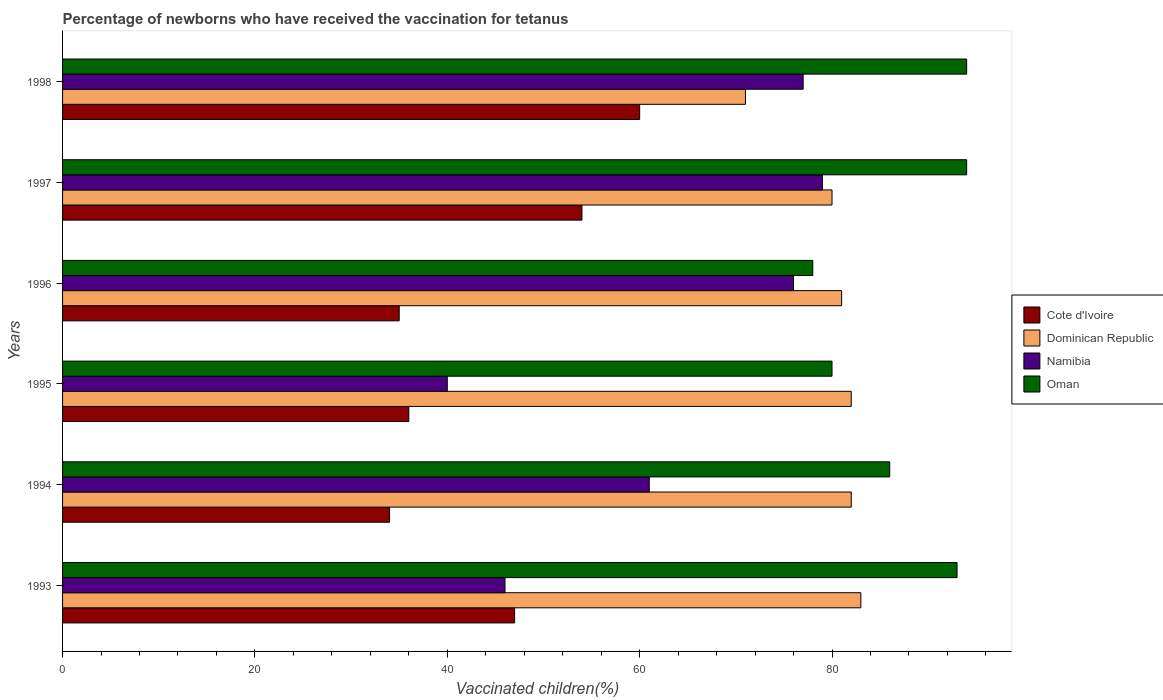How many groups of bars are there?
Your response must be concise. 6. Are the number of bars on each tick of the Y-axis equal?
Provide a succinct answer. Yes. How many bars are there on the 4th tick from the bottom?
Offer a very short reply. 4. What is the percentage of vaccinated children in Cote d'Ivoire in 1998?
Provide a short and direct response. 60. Across all years, what is the maximum percentage of vaccinated children in Namibia?
Your response must be concise. 79. Across all years, what is the minimum percentage of vaccinated children in Oman?
Your response must be concise. 78. In which year was the percentage of vaccinated children in Oman maximum?
Provide a short and direct response. 1997. What is the total percentage of vaccinated children in Cote d'Ivoire in the graph?
Offer a terse response. 266. What is the average percentage of vaccinated children in Dominican Republic per year?
Give a very brief answer. 79.83. In how many years, is the percentage of vaccinated children in Oman greater than 8 %?
Your answer should be very brief. 6. What is the ratio of the percentage of vaccinated children in Cote d'Ivoire in 1993 to that in 1995?
Your response must be concise. 1.31. Is the difference between the percentage of vaccinated children in Oman in 1994 and 1997 greater than the difference between the percentage of vaccinated children in Namibia in 1994 and 1997?
Provide a succinct answer. Yes. What is the difference between the highest and the second highest percentage of vaccinated children in Namibia?
Offer a very short reply. 2. What is the difference between the highest and the lowest percentage of vaccinated children in Dominican Republic?
Your answer should be very brief. 12. In how many years, is the percentage of vaccinated children in Dominican Republic greater than the average percentage of vaccinated children in Dominican Republic taken over all years?
Provide a succinct answer. 5. What does the 2nd bar from the top in 1996 represents?
Provide a succinct answer. Namibia. What does the 1st bar from the bottom in 1993 represents?
Offer a very short reply. Cote d'Ivoire. Is it the case that in every year, the sum of the percentage of vaccinated children in Oman and percentage of vaccinated children in Dominican Republic is greater than the percentage of vaccinated children in Namibia?
Provide a succinct answer. Yes. How many bars are there?
Your answer should be compact. 24. What is the difference between two consecutive major ticks on the X-axis?
Provide a short and direct response. 20. Does the graph contain any zero values?
Keep it short and to the point. No. Does the graph contain grids?
Your answer should be compact. No. Where does the legend appear in the graph?
Provide a succinct answer. Center right. How are the legend labels stacked?
Offer a very short reply. Vertical. What is the title of the graph?
Provide a succinct answer. Percentage of newborns who have received the vaccination for tetanus. What is the label or title of the X-axis?
Provide a short and direct response. Vaccinated children(%). What is the Vaccinated children(%) in Dominican Republic in 1993?
Give a very brief answer. 83. What is the Vaccinated children(%) in Oman in 1993?
Keep it short and to the point. 93. What is the Vaccinated children(%) of Cote d'Ivoire in 1994?
Your answer should be very brief. 34. What is the Vaccinated children(%) in Namibia in 1994?
Give a very brief answer. 61. What is the Vaccinated children(%) in Oman in 1994?
Your answer should be very brief. 86. What is the Vaccinated children(%) of Cote d'Ivoire in 1995?
Give a very brief answer. 36. What is the Vaccinated children(%) in Cote d'Ivoire in 1996?
Provide a succinct answer. 35. What is the Vaccinated children(%) of Dominican Republic in 1996?
Give a very brief answer. 81. What is the Vaccinated children(%) in Oman in 1996?
Your answer should be compact. 78. What is the Vaccinated children(%) in Namibia in 1997?
Offer a terse response. 79. What is the Vaccinated children(%) of Oman in 1997?
Keep it short and to the point. 94. What is the Vaccinated children(%) of Oman in 1998?
Provide a short and direct response. 94. Across all years, what is the maximum Vaccinated children(%) of Namibia?
Provide a succinct answer. 79. Across all years, what is the maximum Vaccinated children(%) of Oman?
Make the answer very short. 94. Across all years, what is the minimum Vaccinated children(%) in Cote d'Ivoire?
Make the answer very short. 34. Across all years, what is the minimum Vaccinated children(%) of Oman?
Ensure brevity in your answer.  78. What is the total Vaccinated children(%) in Cote d'Ivoire in the graph?
Offer a terse response. 266. What is the total Vaccinated children(%) of Dominican Republic in the graph?
Ensure brevity in your answer.  479. What is the total Vaccinated children(%) in Namibia in the graph?
Offer a terse response. 379. What is the total Vaccinated children(%) in Oman in the graph?
Provide a succinct answer. 525. What is the difference between the Vaccinated children(%) in Oman in 1993 and that in 1994?
Offer a terse response. 7. What is the difference between the Vaccinated children(%) of Oman in 1993 and that in 1995?
Give a very brief answer. 13. What is the difference between the Vaccinated children(%) of Cote d'Ivoire in 1993 and that in 1996?
Provide a succinct answer. 12. What is the difference between the Vaccinated children(%) in Dominican Republic in 1993 and that in 1996?
Ensure brevity in your answer.  2. What is the difference between the Vaccinated children(%) of Namibia in 1993 and that in 1996?
Offer a terse response. -30. What is the difference between the Vaccinated children(%) in Cote d'Ivoire in 1993 and that in 1997?
Your answer should be compact. -7. What is the difference between the Vaccinated children(%) in Namibia in 1993 and that in 1997?
Ensure brevity in your answer.  -33. What is the difference between the Vaccinated children(%) of Cote d'Ivoire in 1993 and that in 1998?
Offer a terse response. -13. What is the difference between the Vaccinated children(%) of Namibia in 1993 and that in 1998?
Give a very brief answer. -31. What is the difference between the Vaccinated children(%) in Dominican Republic in 1994 and that in 1995?
Your response must be concise. 0. What is the difference between the Vaccinated children(%) of Oman in 1994 and that in 1995?
Your answer should be very brief. 6. What is the difference between the Vaccinated children(%) in Cote d'Ivoire in 1994 and that in 1996?
Provide a short and direct response. -1. What is the difference between the Vaccinated children(%) in Namibia in 1994 and that in 1996?
Offer a very short reply. -15. What is the difference between the Vaccinated children(%) in Oman in 1994 and that in 1996?
Your answer should be compact. 8. What is the difference between the Vaccinated children(%) of Dominican Republic in 1994 and that in 1997?
Keep it short and to the point. 2. What is the difference between the Vaccinated children(%) of Oman in 1994 and that in 1997?
Provide a succinct answer. -8. What is the difference between the Vaccinated children(%) of Cote d'Ivoire in 1994 and that in 1998?
Offer a very short reply. -26. What is the difference between the Vaccinated children(%) in Cote d'Ivoire in 1995 and that in 1996?
Your response must be concise. 1. What is the difference between the Vaccinated children(%) of Namibia in 1995 and that in 1996?
Provide a succinct answer. -36. What is the difference between the Vaccinated children(%) of Cote d'Ivoire in 1995 and that in 1997?
Give a very brief answer. -18. What is the difference between the Vaccinated children(%) in Namibia in 1995 and that in 1997?
Give a very brief answer. -39. What is the difference between the Vaccinated children(%) of Oman in 1995 and that in 1997?
Offer a very short reply. -14. What is the difference between the Vaccinated children(%) of Cote d'Ivoire in 1995 and that in 1998?
Make the answer very short. -24. What is the difference between the Vaccinated children(%) in Dominican Republic in 1995 and that in 1998?
Give a very brief answer. 11. What is the difference between the Vaccinated children(%) in Namibia in 1995 and that in 1998?
Make the answer very short. -37. What is the difference between the Vaccinated children(%) of Oman in 1995 and that in 1998?
Make the answer very short. -14. What is the difference between the Vaccinated children(%) in Cote d'Ivoire in 1996 and that in 1997?
Offer a very short reply. -19. What is the difference between the Vaccinated children(%) in Oman in 1996 and that in 1997?
Your answer should be compact. -16. What is the difference between the Vaccinated children(%) in Dominican Republic in 1996 and that in 1998?
Offer a very short reply. 10. What is the difference between the Vaccinated children(%) in Oman in 1996 and that in 1998?
Your answer should be compact. -16. What is the difference between the Vaccinated children(%) in Cote d'Ivoire in 1997 and that in 1998?
Your answer should be compact. -6. What is the difference between the Vaccinated children(%) of Namibia in 1997 and that in 1998?
Your answer should be very brief. 2. What is the difference between the Vaccinated children(%) in Cote d'Ivoire in 1993 and the Vaccinated children(%) in Dominican Republic in 1994?
Give a very brief answer. -35. What is the difference between the Vaccinated children(%) of Cote d'Ivoire in 1993 and the Vaccinated children(%) of Oman in 1994?
Give a very brief answer. -39. What is the difference between the Vaccinated children(%) in Cote d'Ivoire in 1993 and the Vaccinated children(%) in Dominican Republic in 1995?
Your response must be concise. -35. What is the difference between the Vaccinated children(%) of Cote d'Ivoire in 1993 and the Vaccinated children(%) of Namibia in 1995?
Make the answer very short. 7. What is the difference between the Vaccinated children(%) of Cote d'Ivoire in 1993 and the Vaccinated children(%) of Oman in 1995?
Your answer should be very brief. -33. What is the difference between the Vaccinated children(%) of Dominican Republic in 1993 and the Vaccinated children(%) of Namibia in 1995?
Your answer should be very brief. 43. What is the difference between the Vaccinated children(%) of Namibia in 1993 and the Vaccinated children(%) of Oman in 1995?
Keep it short and to the point. -34. What is the difference between the Vaccinated children(%) in Cote d'Ivoire in 1993 and the Vaccinated children(%) in Dominican Republic in 1996?
Provide a succinct answer. -34. What is the difference between the Vaccinated children(%) of Cote d'Ivoire in 1993 and the Vaccinated children(%) of Namibia in 1996?
Give a very brief answer. -29. What is the difference between the Vaccinated children(%) in Cote d'Ivoire in 1993 and the Vaccinated children(%) in Oman in 1996?
Your answer should be compact. -31. What is the difference between the Vaccinated children(%) of Dominican Republic in 1993 and the Vaccinated children(%) of Namibia in 1996?
Offer a terse response. 7. What is the difference between the Vaccinated children(%) in Dominican Republic in 1993 and the Vaccinated children(%) in Oman in 1996?
Provide a short and direct response. 5. What is the difference between the Vaccinated children(%) of Namibia in 1993 and the Vaccinated children(%) of Oman in 1996?
Offer a very short reply. -32. What is the difference between the Vaccinated children(%) in Cote d'Ivoire in 1993 and the Vaccinated children(%) in Dominican Republic in 1997?
Your answer should be very brief. -33. What is the difference between the Vaccinated children(%) in Cote d'Ivoire in 1993 and the Vaccinated children(%) in Namibia in 1997?
Your answer should be compact. -32. What is the difference between the Vaccinated children(%) in Cote d'Ivoire in 1993 and the Vaccinated children(%) in Oman in 1997?
Offer a very short reply. -47. What is the difference between the Vaccinated children(%) in Dominican Republic in 1993 and the Vaccinated children(%) in Namibia in 1997?
Your answer should be compact. 4. What is the difference between the Vaccinated children(%) in Dominican Republic in 1993 and the Vaccinated children(%) in Oman in 1997?
Provide a succinct answer. -11. What is the difference between the Vaccinated children(%) of Namibia in 1993 and the Vaccinated children(%) of Oman in 1997?
Offer a very short reply. -48. What is the difference between the Vaccinated children(%) in Cote d'Ivoire in 1993 and the Vaccinated children(%) in Dominican Republic in 1998?
Provide a short and direct response. -24. What is the difference between the Vaccinated children(%) in Cote d'Ivoire in 1993 and the Vaccinated children(%) in Oman in 1998?
Your answer should be compact. -47. What is the difference between the Vaccinated children(%) of Dominican Republic in 1993 and the Vaccinated children(%) of Namibia in 1998?
Keep it short and to the point. 6. What is the difference between the Vaccinated children(%) of Namibia in 1993 and the Vaccinated children(%) of Oman in 1998?
Provide a short and direct response. -48. What is the difference between the Vaccinated children(%) of Cote d'Ivoire in 1994 and the Vaccinated children(%) of Dominican Republic in 1995?
Your answer should be very brief. -48. What is the difference between the Vaccinated children(%) in Cote d'Ivoire in 1994 and the Vaccinated children(%) in Oman in 1995?
Offer a terse response. -46. What is the difference between the Vaccinated children(%) of Dominican Republic in 1994 and the Vaccinated children(%) of Namibia in 1995?
Your response must be concise. 42. What is the difference between the Vaccinated children(%) in Dominican Republic in 1994 and the Vaccinated children(%) in Oman in 1995?
Offer a terse response. 2. What is the difference between the Vaccinated children(%) of Namibia in 1994 and the Vaccinated children(%) of Oman in 1995?
Provide a short and direct response. -19. What is the difference between the Vaccinated children(%) in Cote d'Ivoire in 1994 and the Vaccinated children(%) in Dominican Republic in 1996?
Provide a succinct answer. -47. What is the difference between the Vaccinated children(%) in Cote d'Ivoire in 1994 and the Vaccinated children(%) in Namibia in 1996?
Offer a very short reply. -42. What is the difference between the Vaccinated children(%) in Cote d'Ivoire in 1994 and the Vaccinated children(%) in Oman in 1996?
Provide a short and direct response. -44. What is the difference between the Vaccinated children(%) in Cote d'Ivoire in 1994 and the Vaccinated children(%) in Dominican Republic in 1997?
Provide a succinct answer. -46. What is the difference between the Vaccinated children(%) of Cote d'Ivoire in 1994 and the Vaccinated children(%) of Namibia in 1997?
Make the answer very short. -45. What is the difference between the Vaccinated children(%) of Cote d'Ivoire in 1994 and the Vaccinated children(%) of Oman in 1997?
Offer a terse response. -60. What is the difference between the Vaccinated children(%) of Namibia in 1994 and the Vaccinated children(%) of Oman in 1997?
Provide a short and direct response. -33. What is the difference between the Vaccinated children(%) in Cote d'Ivoire in 1994 and the Vaccinated children(%) in Dominican Republic in 1998?
Offer a terse response. -37. What is the difference between the Vaccinated children(%) in Cote d'Ivoire in 1994 and the Vaccinated children(%) in Namibia in 1998?
Provide a short and direct response. -43. What is the difference between the Vaccinated children(%) of Cote d'Ivoire in 1994 and the Vaccinated children(%) of Oman in 1998?
Ensure brevity in your answer.  -60. What is the difference between the Vaccinated children(%) in Dominican Republic in 1994 and the Vaccinated children(%) in Namibia in 1998?
Provide a succinct answer. 5. What is the difference between the Vaccinated children(%) in Dominican Republic in 1994 and the Vaccinated children(%) in Oman in 1998?
Offer a very short reply. -12. What is the difference between the Vaccinated children(%) of Namibia in 1994 and the Vaccinated children(%) of Oman in 1998?
Your answer should be very brief. -33. What is the difference between the Vaccinated children(%) in Cote d'Ivoire in 1995 and the Vaccinated children(%) in Dominican Republic in 1996?
Provide a short and direct response. -45. What is the difference between the Vaccinated children(%) in Cote d'Ivoire in 1995 and the Vaccinated children(%) in Namibia in 1996?
Offer a very short reply. -40. What is the difference between the Vaccinated children(%) of Cote d'Ivoire in 1995 and the Vaccinated children(%) of Oman in 1996?
Make the answer very short. -42. What is the difference between the Vaccinated children(%) in Dominican Republic in 1995 and the Vaccinated children(%) in Oman in 1996?
Provide a short and direct response. 4. What is the difference between the Vaccinated children(%) of Namibia in 1995 and the Vaccinated children(%) of Oman in 1996?
Your response must be concise. -38. What is the difference between the Vaccinated children(%) of Cote d'Ivoire in 1995 and the Vaccinated children(%) of Dominican Republic in 1997?
Your response must be concise. -44. What is the difference between the Vaccinated children(%) in Cote d'Ivoire in 1995 and the Vaccinated children(%) in Namibia in 1997?
Offer a very short reply. -43. What is the difference between the Vaccinated children(%) in Cote d'Ivoire in 1995 and the Vaccinated children(%) in Oman in 1997?
Give a very brief answer. -58. What is the difference between the Vaccinated children(%) of Dominican Republic in 1995 and the Vaccinated children(%) of Namibia in 1997?
Offer a terse response. 3. What is the difference between the Vaccinated children(%) of Namibia in 1995 and the Vaccinated children(%) of Oman in 1997?
Your answer should be compact. -54. What is the difference between the Vaccinated children(%) of Cote d'Ivoire in 1995 and the Vaccinated children(%) of Dominican Republic in 1998?
Offer a terse response. -35. What is the difference between the Vaccinated children(%) in Cote d'Ivoire in 1995 and the Vaccinated children(%) in Namibia in 1998?
Your answer should be very brief. -41. What is the difference between the Vaccinated children(%) in Cote d'Ivoire in 1995 and the Vaccinated children(%) in Oman in 1998?
Offer a very short reply. -58. What is the difference between the Vaccinated children(%) of Dominican Republic in 1995 and the Vaccinated children(%) of Namibia in 1998?
Provide a short and direct response. 5. What is the difference between the Vaccinated children(%) in Namibia in 1995 and the Vaccinated children(%) in Oman in 1998?
Make the answer very short. -54. What is the difference between the Vaccinated children(%) of Cote d'Ivoire in 1996 and the Vaccinated children(%) of Dominican Republic in 1997?
Offer a terse response. -45. What is the difference between the Vaccinated children(%) in Cote d'Ivoire in 1996 and the Vaccinated children(%) in Namibia in 1997?
Provide a succinct answer. -44. What is the difference between the Vaccinated children(%) in Cote d'Ivoire in 1996 and the Vaccinated children(%) in Oman in 1997?
Make the answer very short. -59. What is the difference between the Vaccinated children(%) in Dominican Republic in 1996 and the Vaccinated children(%) in Namibia in 1997?
Make the answer very short. 2. What is the difference between the Vaccinated children(%) of Cote d'Ivoire in 1996 and the Vaccinated children(%) of Dominican Republic in 1998?
Your answer should be very brief. -36. What is the difference between the Vaccinated children(%) of Cote d'Ivoire in 1996 and the Vaccinated children(%) of Namibia in 1998?
Offer a very short reply. -42. What is the difference between the Vaccinated children(%) in Cote d'Ivoire in 1996 and the Vaccinated children(%) in Oman in 1998?
Your answer should be compact. -59. What is the difference between the Vaccinated children(%) in Dominican Republic in 1996 and the Vaccinated children(%) in Oman in 1998?
Give a very brief answer. -13. What is the difference between the Vaccinated children(%) in Namibia in 1996 and the Vaccinated children(%) in Oman in 1998?
Your answer should be compact. -18. What is the difference between the Vaccinated children(%) of Cote d'Ivoire in 1997 and the Vaccinated children(%) of Namibia in 1998?
Your answer should be compact. -23. What is the difference between the Vaccinated children(%) of Dominican Republic in 1997 and the Vaccinated children(%) of Oman in 1998?
Keep it short and to the point. -14. What is the difference between the Vaccinated children(%) of Namibia in 1997 and the Vaccinated children(%) of Oman in 1998?
Make the answer very short. -15. What is the average Vaccinated children(%) in Cote d'Ivoire per year?
Give a very brief answer. 44.33. What is the average Vaccinated children(%) in Dominican Republic per year?
Give a very brief answer. 79.83. What is the average Vaccinated children(%) of Namibia per year?
Provide a succinct answer. 63.17. What is the average Vaccinated children(%) in Oman per year?
Keep it short and to the point. 87.5. In the year 1993, what is the difference between the Vaccinated children(%) in Cote d'Ivoire and Vaccinated children(%) in Dominican Republic?
Your answer should be compact. -36. In the year 1993, what is the difference between the Vaccinated children(%) in Cote d'Ivoire and Vaccinated children(%) in Oman?
Give a very brief answer. -46. In the year 1993, what is the difference between the Vaccinated children(%) of Dominican Republic and Vaccinated children(%) of Namibia?
Make the answer very short. 37. In the year 1993, what is the difference between the Vaccinated children(%) of Namibia and Vaccinated children(%) of Oman?
Provide a succinct answer. -47. In the year 1994, what is the difference between the Vaccinated children(%) of Cote d'Ivoire and Vaccinated children(%) of Dominican Republic?
Keep it short and to the point. -48. In the year 1994, what is the difference between the Vaccinated children(%) of Cote d'Ivoire and Vaccinated children(%) of Oman?
Your response must be concise. -52. In the year 1995, what is the difference between the Vaccinated children(%) in Cote d'Ivoire and Vaccinated children(%) in Dominican Republic?
Give a very brief answer. -46. In the year 1995, what is the difference between the Vaccinated children(%) of Cote d'Ivoire and Vaccinated children(%) of Namibia?
Keep it short and to the point. -4. In the year 1995, what is the difference between the Vaccinated children(%) of Cote d'Ivoire and Vaccinated children(%) of Oman?
Your answer should be compact. -44. In the year 1995, what is the difference between the Vaccinated children(%) of Dominican Republic and Vaccinated children(%) of Namibia?
Your answer should be very brief. 42. In the year 1995, what is the difference between the Vaccinated children(%) in Dominican Republic and Vaccinated children(%) in Oman?
Provide a short and direct response. 2. In the year 1996, what is the difference between the Vaccinated children(%) in Cote d'Ivoire and Vaccinated children(%) in Dominican Republic?
Make the answer very short. -46. In the year 1996, what is the difference between the Vaccinated children(%) in Cote d'Ivoire and Vaccinated children(%) in Namibia?
Offer a terse response. -41. In the year 1996, what is the difference between the Vaccinated children(%) in Cote d'Ivoire and Vaccinated children(%) in Oman?
Make the answer very short. -43. In the year 1996, what is the difference between the Vaccinated children(%) of Dominican Republic and Vaccinated children(%) of Namibia?
Your answer should be very brief. 5. In the year 1996, what is the difference between the Vaccinated children(%) in Namibia and Vaccinated children(%) in Oman?
Give a very brief answer. -2. In the year 1997, what is the difference between the Vaccinated children(%) of Dominican Republic and Vaccinated children(%) of Namibia?
Your response must be concise. 1. In the year 1997, what is the difference between the Vaccinated children(%) in Namibia and Vaccinated children(%) in Oman?
Give a very brief answer. -15. In the year 1998, what is the difference between the Vaccinated children(%) in Cote d'Ivoire and Vaccinated children(%) in Namibia?
Your answer should be compact. -17. In the year 1998, what is the difference between the Vaccinated children(%) in Cote d'Ivoire and Vaccinated children(%) in Oman?
Offer a very short reply. -34. What is the ratio of the Vaccinated children(%) of Cote d'Ivoire in 1993 to that in 1994?
Provide a short and direct response. 1.38. What is the ratio of the Vaccinated children(%) in Dominican Republic in 1993 to that in 1994?
Keep it short and to the point. 1.01. What is the ratio of the Vaccinated children(%) of Namibia in 1993 to that in 1994?
Your response must be concise. 0.75. What is the ratio of the Vaccinated children(%) in Oman in 1993 to that in 1994?
Keep it short and to the point. 1.08. What is the ratio of the Vaccinated children(%) of Cote d'Ivoire in 1993 to that in 1995?
Your answer should be very brief. 1.31. What is the ratio of the Vaccinated children(%) of Dominican Republic in 1993 to that in 1995?
Provide a succinct answer. 1.01. What is the ratio of the Vaccinated children(%) of Namibia in 1993 to that in 1995?
Ensure brevity in your answer.  1.15. What is the ratio of the Vaccinated children(%) in Oman in 1993 to that in 1995?
Your answer should be compact. 1.16. What is the ratio of the Vaccinated children(%) of Cote d'Ivoire in 1993 to that in 1996?
Keep it short and to the point. 1.34. What is the ratio of the Vaccinated children(%) in Dominican Republic in 1993 to that in 1996?
Offer a terse response. 1.02. What is the ratio of the Vaccinated children(%) of Namibia in 1993 to that in 1996?
Your answer should be very brief. 0.61. What is the ratio of the Vaccinated children(%) of Oman in 1993 to that in 1996?
Provide a succinct answer. 1.19. What is the ratio of the Vaccinated children(%) in Cote d'Ivoire in 1993 to that in 1997?
Make the answer very short. 0.87. What is the ratio of the Vaccinated children(%) of Dominican Republic in 1993 to that in 1997?
Your answer should be compact. 1.04. What is the ratio of the Vaccinated children(%) in Namibia in 1993 to that in 1997?
Your answer should be compact. 0.58. What is the ratio of the Vaccinated children(%) in Oman in 1993 to that in 1997?
Give a very brief answer. 0.99. What is the ratio of the Vaccinated children(%) of Cote d'Ivoire in 1993 to that in 1998?
Your answer should be very brief. 0.78. What is the ratio of the Vaccinated children(%) of Dominican Republic in 1993 to that in 1998?
Your answer should be very brief. 1.17. What is the ratio of the Vaccinated children(%) of Namibia in 1993 to that in 1998?
Ensure brevity in your answer.  0.6. What is the ratio of the Vaccinated children(%) of Oman in 1993 to that in 1998?
Make the answer very short. 0.99. What is the ratio of the Vaccinated children(%) in Namibia in 1994 to that in 1995?
Provide a short and direct response. 1.52. What is the ratio of the Vaccinated children(%) of Oman in 1994 to that in 1995?
Your response must be concise. 1.07. What is the ratio of the Vaccinated children(%) in Cote d'Ivoire in 1994 to that in 1996?
Offer a very short reply. 0.97. What is the ratio of the Vaccinated children(%) in Dominican Republic in 1994 to that in 1996?
Your answer should be compact. 1.01. What is the ratio of the Vaccinated children(%) of Namibia in 1994 to that in 1996?
Give a very brief answer. 0.8. What is the ratio of the Vaccinated children(%) of Oman in 1994 to that in 1996?
Provide a succinct answer. 1.1. What is the ratio of the Vaccinated children(%) of Cote d'Ivoire in 1994 to that in 1997?
Give a very brief answer. 0.63. What is the ratio of the Vaccinated children(%) in Dominican Republic in 1994 to that in 1997?
Provide a short and direct response. 1.02. What is the ratio of the Vaccinated children(%) of Namibia in 1994 to that in 1997?
Your answer should be very brief. 0.77. What is the ratio of the Vaccinated children(%) of Oman in 1994 to that in 1997?
Keep it short and to the point. 0.91. What is the ratio of the Vaccinated children(%) of Cote d'Ivoire in 1994 to that in 1998?
Provide a succinct answer. 0.57. What is the ratio of the Vaccinated children(%) in Dominican Republic in 1994 to that in 1998?
Give a very brief answer. 1.15. What is the ratio of the Vaccinated children(%) of Namibia in 1994 to that in 1998?
Ensure brevity in your answer.  0.79. What is the ratio of the Vaccinated children(%) in Oman in 1994 to that in 1998?
Provide a succinct answer. 0.91. What is the ratio of the Vaccinated children(%) in Cote d'Ivoire in 1995 to that in 1996?
Offer a very short reply. 1.03. What is the ratio of the Vaccinated children(%) in Dominican Republic in 1995 to that in 1996?
Your answer should be very brief. 1.01. What is the ratio of the Vaccinated children(%) of Namibia in 1995 to that in 1996?
Ensure brevity in your answer.  0.53. What is the ratio of the Vaccinated children(%) of Oman in 1995 to that in 1996?
Provide a succinct answer. 1.03. What is the ratio of the Vaccinated children(%) of Cote d'Ivoire in 1995 to that in 1997?
Provide a short and direct response. 0.67. What is the ratio of the Vaccinated children(%) of Namibia in 1995 to that in 1997?
Keep it short and to the point. 0.51. What is the ratio of the Vaccinated children(%) in Oman in 1995 to that in 1997?
Your response must be concise. 0.85. What is the ratio of the Vaccinated children(%) in Dominican Republic in 1995 to that in 1998?
Provide a short and direct response. 1.15. What is the ratio of the Vaccinated children(%) in Namibia in 1995 to that in 1998?
Your answer should be very brief. 0.52. What is the ratio of the Vaccinated children(%) in Oman in 1995 to that in 1998?
Offer a terse response. 0.85. What is the ratio of the Vaccinated children(%) in Cote d'Ivoire in 1996 to that in 1997?
Ensure brevity in your answer.  0.65. What is the ratio of the Vaccinated children(%) in Dominican Republic in 1996 to that in 1997?
Your answer should be very brief. 1.01. What is the ratio of the Vaccinated children(%) of Oman in 1996 to that in 1997?
Your answer should be compact. 0.83. What is the ratio of the Vaccinated children(%) of Cote d'Ivoire in 1996 to that in 1998?
Give a very brief answer. 0.58. What is the ratio of the Vaccinated children(%) in Dominican Republic in 1996 to that in 1998?
Your answer should be very brief. 1.14. What is the ratio of the Vaccinated children(%) in Namibia in 1996 to that in 1998?
Provide a short and direct response. 0.99. What is the ratio of the Vaccinated children(%) in Oman in 1996 to that in 1998?
Give a very brief answer. 0.83. What is the ratio of the Vaccinated children(%) of Dominican Republic in 1997 to that in 1998?
Your answer should be very brief. 1.13. What is the difference between the highest and the second highest Vaccinated children(%) in Cote d'Ivoire?
Your answer should be compact. 6. What is the difference between the highest and the second highest Vaccinated children(%) in Dominican Republic?
Ensure brevity in your answer.  1. What is the difference between the highest and the second highest Vaccinated children(%) in Namibia?
Offer a very short reply. 2. What is the difference between the highest and the lowest Vaccinated children(%) in Dominican Republic?
Give a very brief answer. 12. 